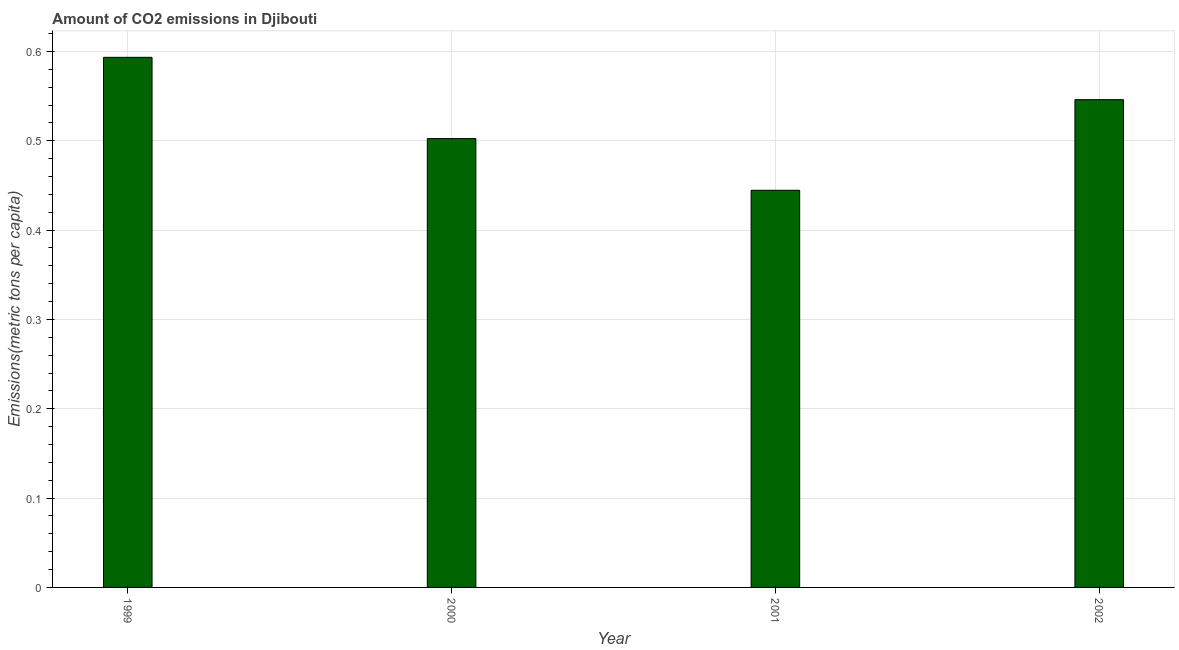Does the graph contain grids?
Provide a short and direct response. Yes. What is the title of the graph?
Offer a very short reply. Amount of CO2 emissions in Djibouti. What is the label or title of the Y-axis?
Your response must be concise. Emissions(metric tons per capita). What is the amount of co2 emissions in 1999?
Ensure brevity in your answer.  0.59. Across all years, what is the maximum amount of co2 emissions?
Offer a terse response. 0.59. Across all years, what is the minimum amount of co2 emissions?
Keep it short and to the point. 0.44. In which year was the amount of co2 emissions maximum?
Provide a short and direct response. 1999. What is the sum of the amount of co2 emissions?
Provide a short and direct response. 2.09. What is the difference between the amount of co2 emissions in 2001 and 2002?
Provide a short and direct response. -0.1. What is the average amount of co2 emissions per year?
Offer a very short reply. 0.52. What is the median amount of co2 emissions?
Your answer should be very brief. 0.52. In how many years, is the amount of co2 emissions greater than 0.32 metric tons per capita?
Offer a terse response. 4. Do a majority of the years between 2002 and 2001 (inclusive) have amount of co2 emissions greater than 0.56 metric tons per capita?
Offer a terse response. No. What is the ratio of the amount of co2 emissions in 2000 to that in 2001?
Offer a terse response. 1.13. Is the difference between the amount of co2 emissions in 2000 and 2002 greater than the difference between any two years?
Your answer should be compact. No. What is the difference between the highest and the second highest amount of co2 emissions?
Make the answer very short. 0.05. What is the difference between the highest and the lowest amount of co2 emissions?
Give a very brief answer. 0.15. In how many years, is the amount of co2 emissions greater than the average amount of co2 emissions taken over all years?
Keep it short and to the point. 2. How many years are there in the graph?
Give a very brief answer. 4. What is the difference between two consecutive major ticks on the Y-axis?
Make the answer very short. 0.1. What is the Emissions(metric tons per capita) in 1999?
Provide a short and direct response. 0.59. What is the Emissions(metric tons per capita) in 2000?
Offer a terse response. 0.5. What is the Emissions(metric tons per capita) of 2001?
Keep it short and to the point. 0.44. What is the Emissions(metric tons per capita) of 2002?
Offer a very short reply. 0.55. What is the difference between the Emissions(metric tons per capita) in 1999 and 2000?
Make the answer very short. 0.09. What is the difference between the Emissions(metric tons per capita) in 1999 and 2001?
Your response must be concise. 0.15. What is the difference between the Emissions(metric tons per capita) in 1999 and 2002?
Provide a short and direct response. 0.05. What is the difference between the Emissions(metric tons per capita) in 2000 and 2001?
Provide a succinct answer. 0.06. What is the difference between the Emissions(metric tons per capita) in 2000 and 2002?
Make the answer very short. -0.04. What is the difference between the Emissions(metric tons per capita) in 2001 and 2002?
Offer a very short reply. -0.1. What is the ratio of the Emissions(metric tons per capita) in 1999 to that in 2000?
Give a very brief answer. 1.18. What is the ratio of the Emissions(metric tons per capita) in 1999 to that in 2001?
Keep it short and to the point. 1.33. What is the ratio of the Emissions(metric tons per capita) in 1999 to that in 2002?
Offer a very short reply. 1.09. What is the ratio of the Emissions(metric tons per capita) in 2000 to that in 2001?
Keep it short and to the point. 1.13. What is the ratio of the Emissions(metric tons per capita) in 2000 to that in 2002?
Make the answer very short. 0.92. What is the ratio of the Emissions(metric tons per capita) in 2001 to that in 2002?
Your response must be concise. 0.81. 